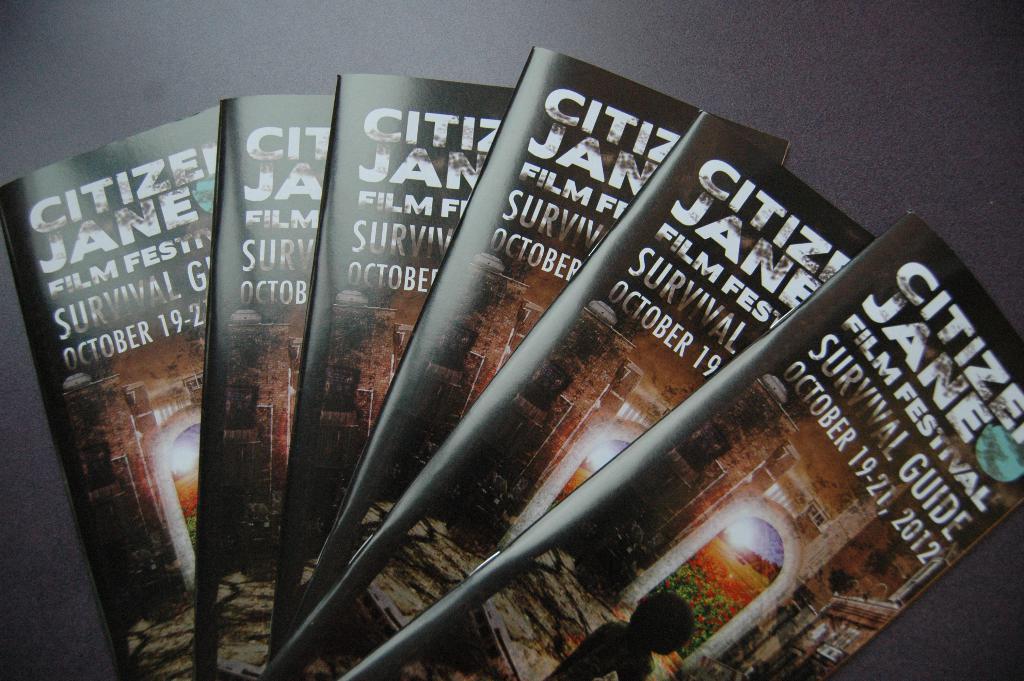What is the date of this event?
Give a very brief answer. October 19-21, 2012. 